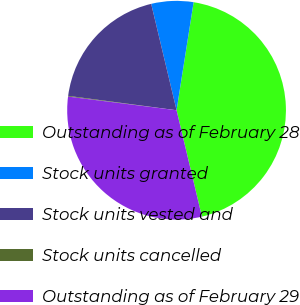Convert chart. <chart><loc_0><loc_0><loc_500><loc_500><pie_chart><fcel>Outstanding as of February 28<fcel>Stock units granted<fcel>Stock units vested and<fcel>Stock units cancelled<fcel>Outstanding as of February 29<nl><fcel>43.78%<fcel>6.22%<fcel>19.17%<fcel>0.11%<fcel>30.71%<nl></chart> 